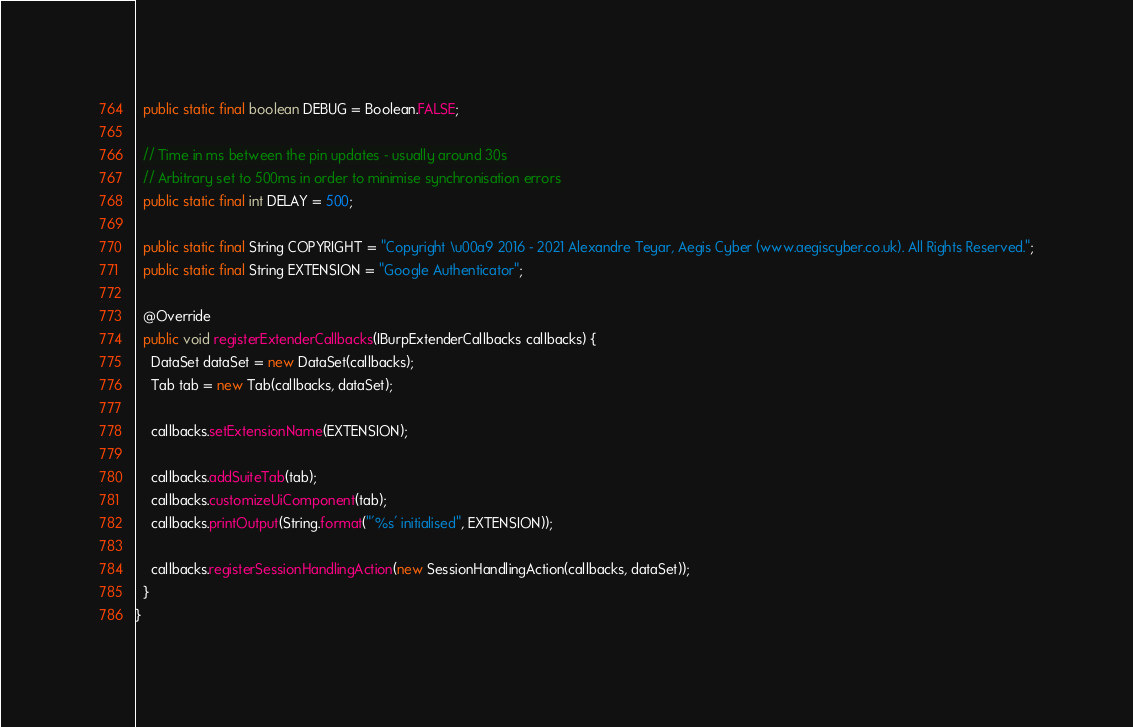<code> <loc_0><loc_0><loc_500><loc_500><_Java_>
  public static final boolean DEBUG = Boolean.FALSE;

  // Time in ms between the pin updates - usually around 30s
  // Arbitrary set to 500ms in order to minimise synchronisation errors
  public static final int DELAY = 500;

  public static final String COPYRIGHT = "Copyright \u00a9 2016 - 2021 Alexandre Teyar, Aegis Cyber (www.aegiscyber.co.uk). All Rights Reserved.";
  public static final String EXTENSION = "Google Authenticator";

  @Override
  public void registerExtenderCallbacks(IBurpExtenderCallbacks callbacks) {
    DataSet dataSet = new DataSet(callbacks);
    Tab tab = new Tab(callbacks, dataSet);

    callbacks.setExtensionName(EXTENSION);

    callbacks.addSuiteTab(tab);
    callbacks.customizeUiComponent(tab);
    callbacks.printOutput(String.format("'%s' initialised", EXTENSION));

    callbacks.registerSessionHandlingAction(new SessionHandlingAction(callbacks, dataSet));
  }
}
</code> 